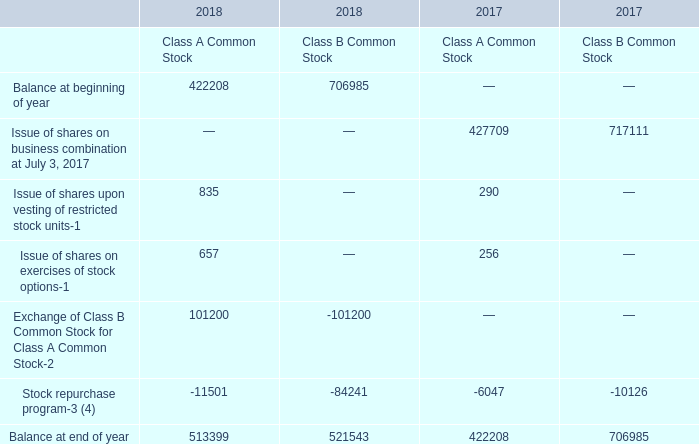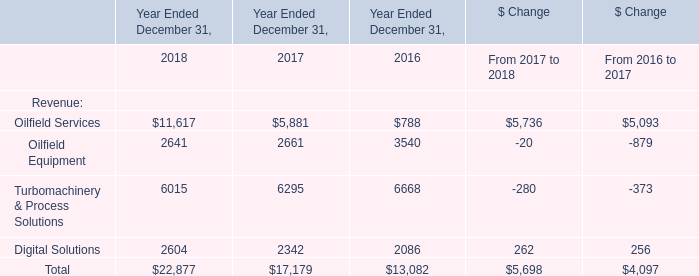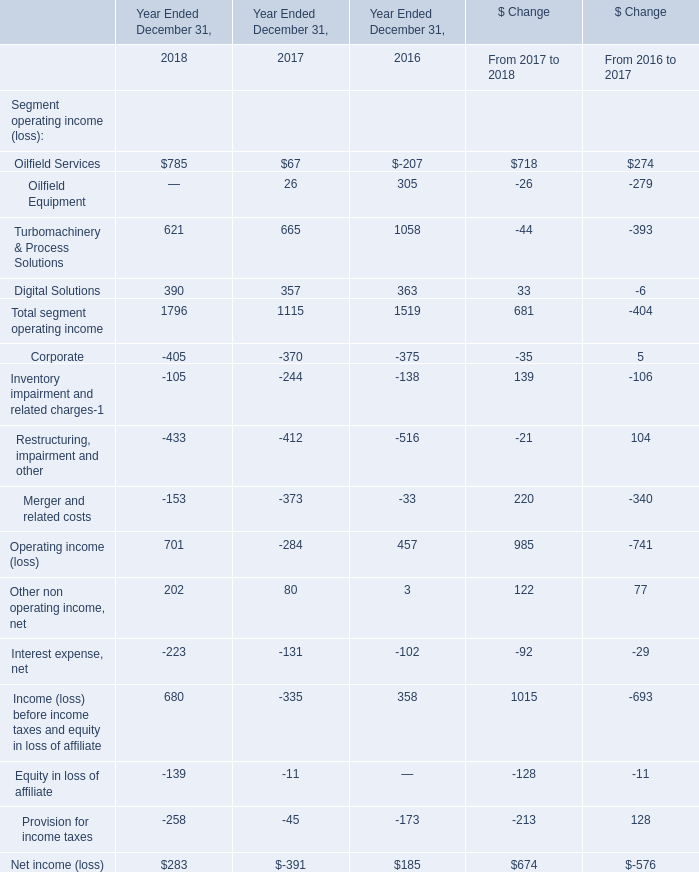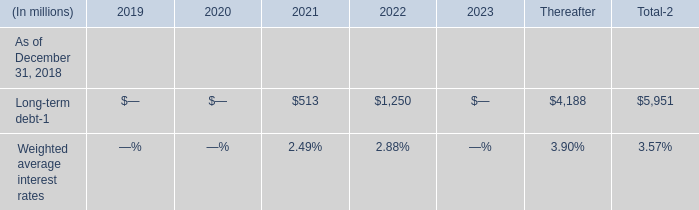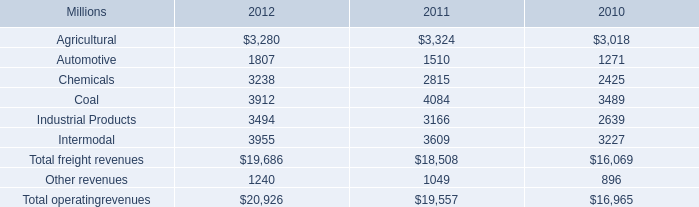If Total develops with the same increasing rate in 2018, what will it reach in 2019? (in million) 
Computations: (exp((1 + ((22877 - 17179) / 17179)) * 2))
Answer: 395246.14098. 